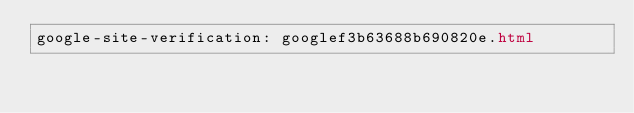Convert code to text. <code><loc_0><loc_0><loc_500><loc_500><_HTML_>google-site-verification: googlef3b63688b690820e.html</code> 